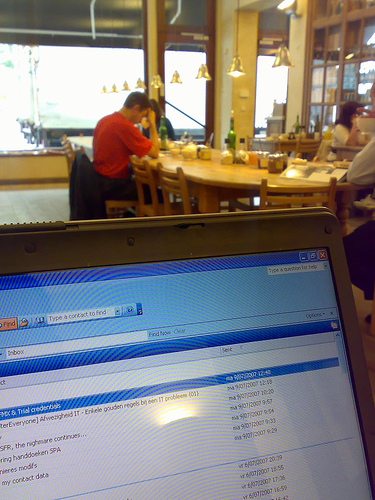<image>
Is the light on the wall? No. The light is not positioned on the wall. They may be near each other, but the light is not supported by or resting on top of the wall. 